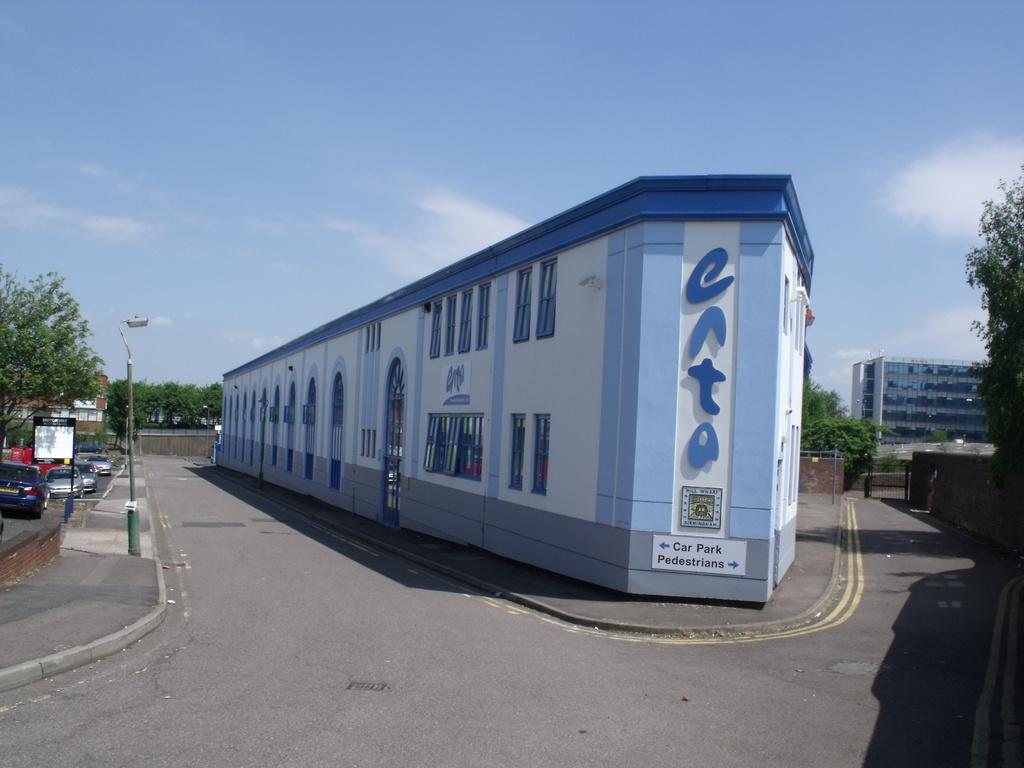Who can park on the right side?
Your response must be concise. Pedestrians. What is to the left of the blue building?
Make the answer very short. Car park. 